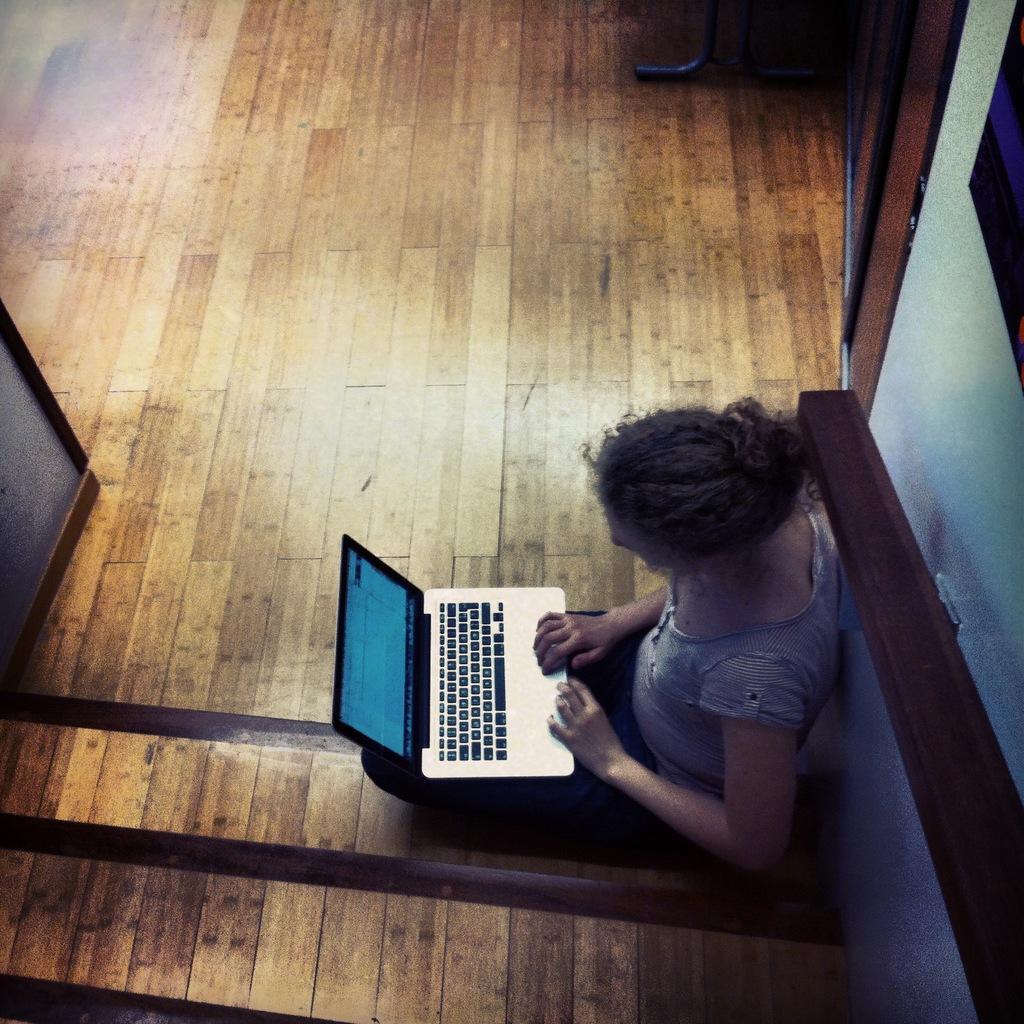Describe this image in one or two sentences. In this picture there is a woman, who is holding laptop. She is sitting near to the wall. Here we can see wooden floor. 